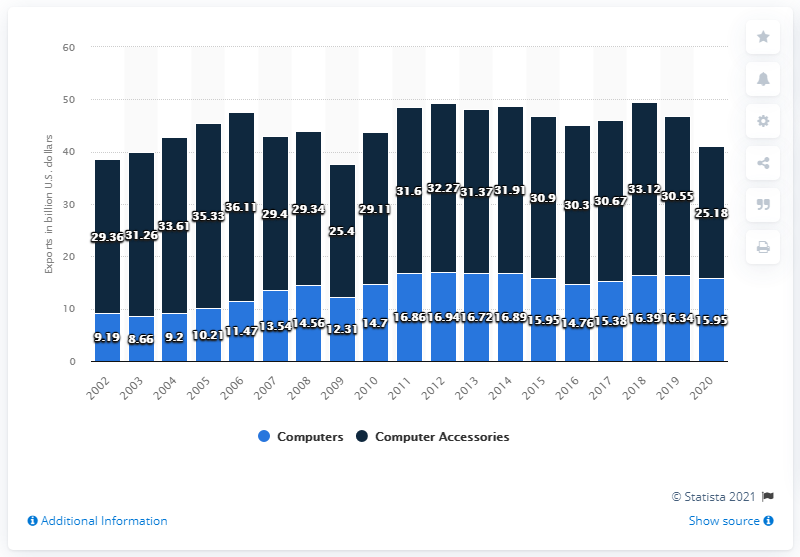Indicate a few pertinent items in this graphic. According to data from 2020, the export value of computer accessories in the United States was approximately 25.18 billion U.S. dollars. In 2020, the export value of computers from the United States amounted to $15.95 billion in dollars. 